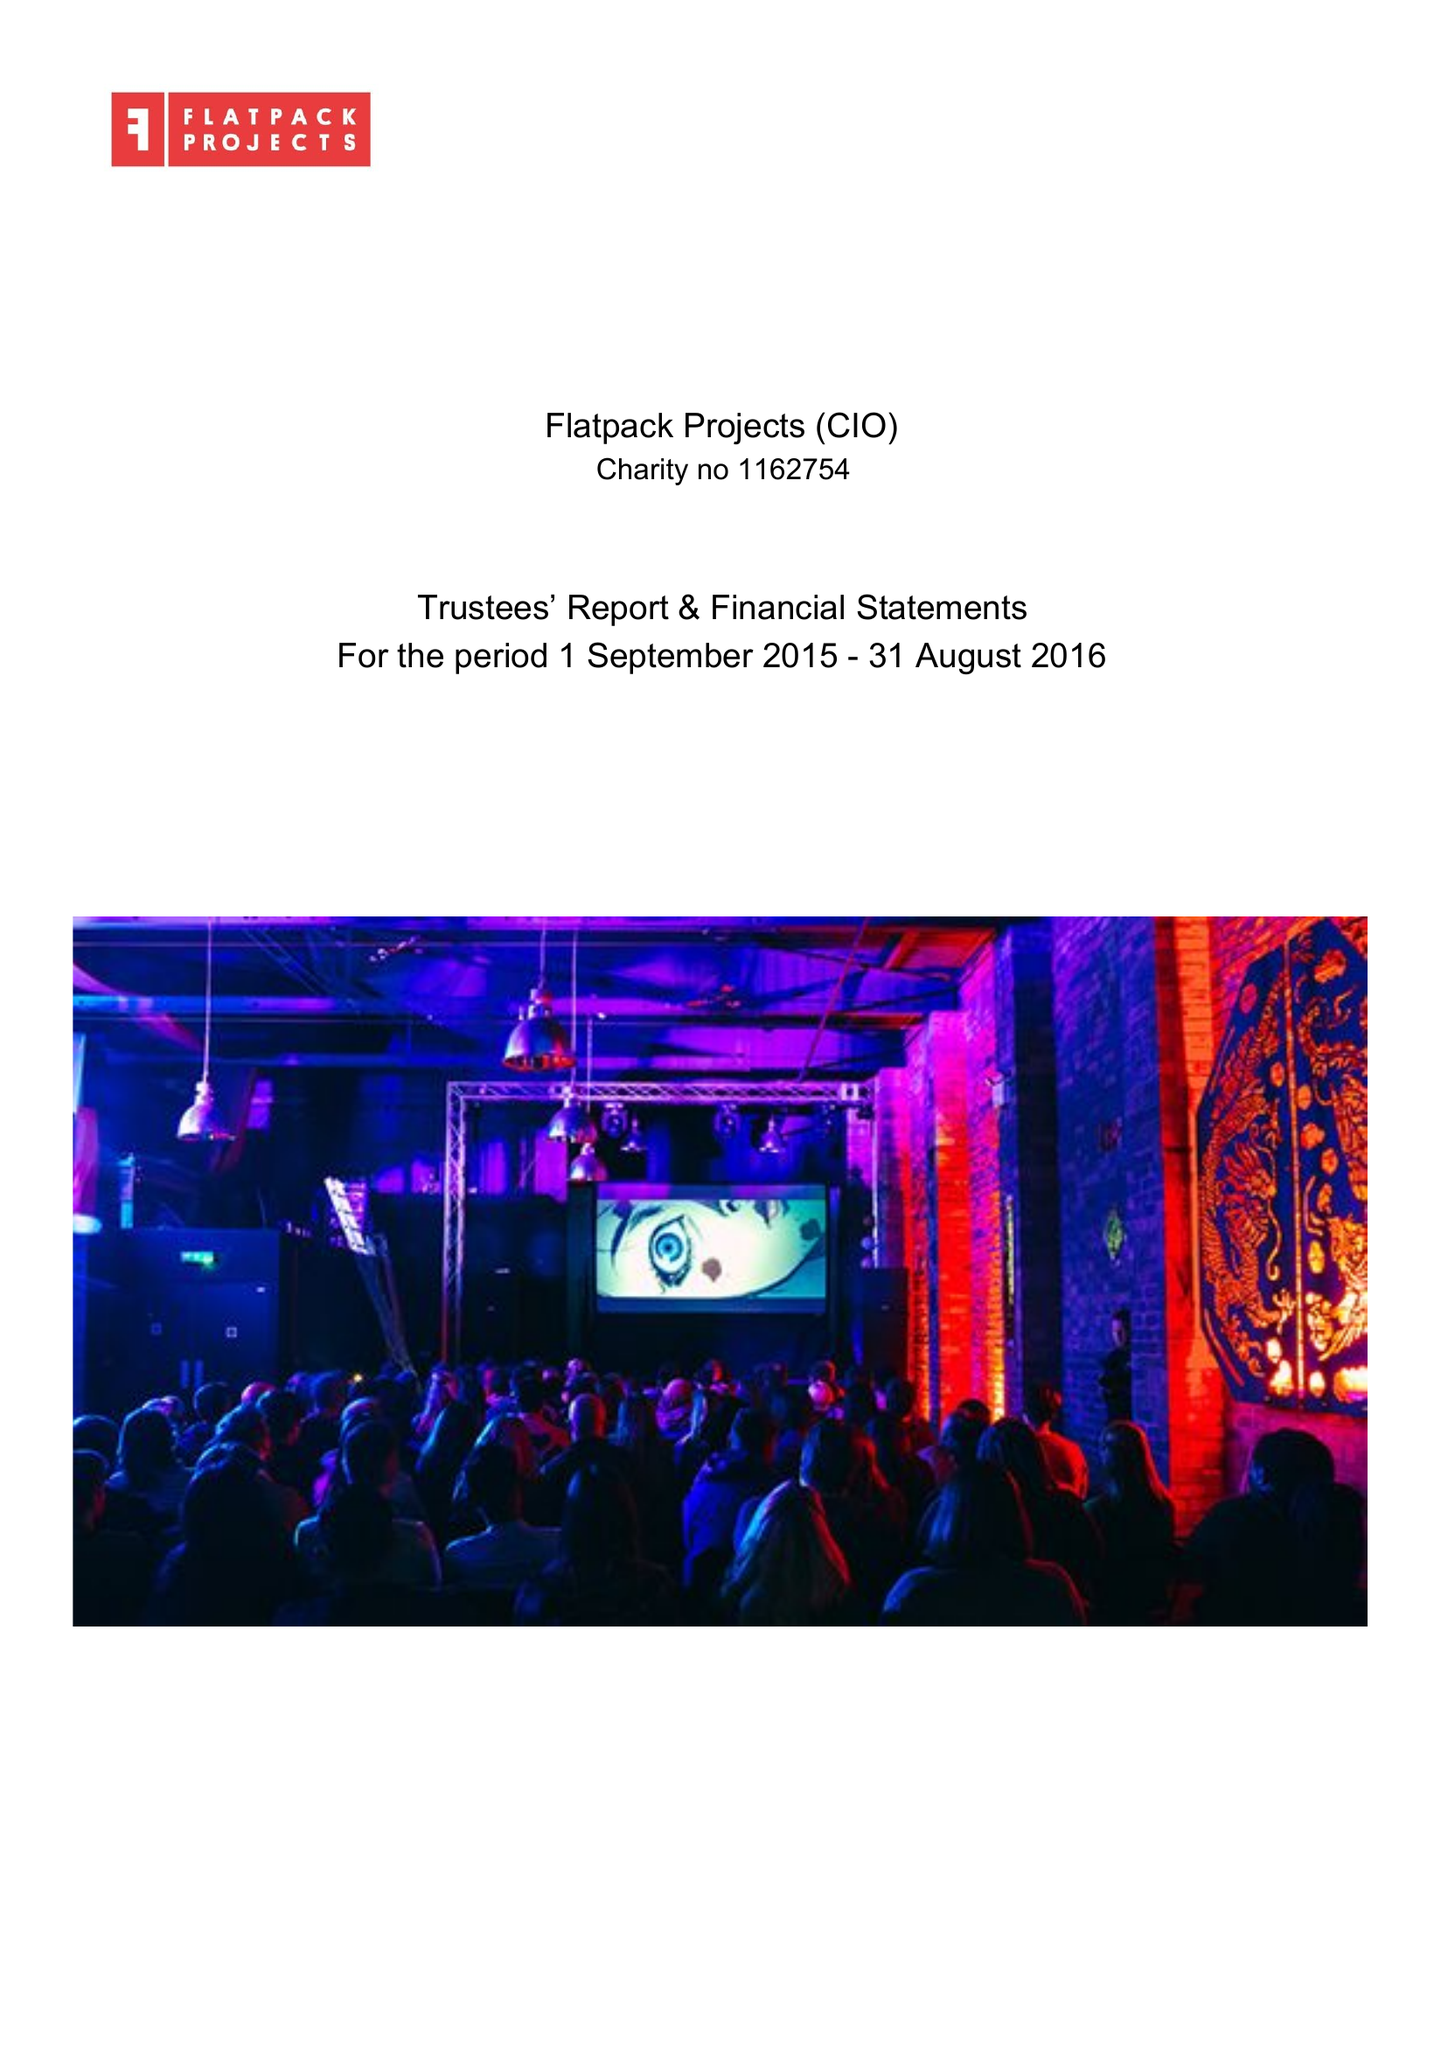What is the value for the address__postcode?
Answer the question using a single word or phrase. B9 4AA 